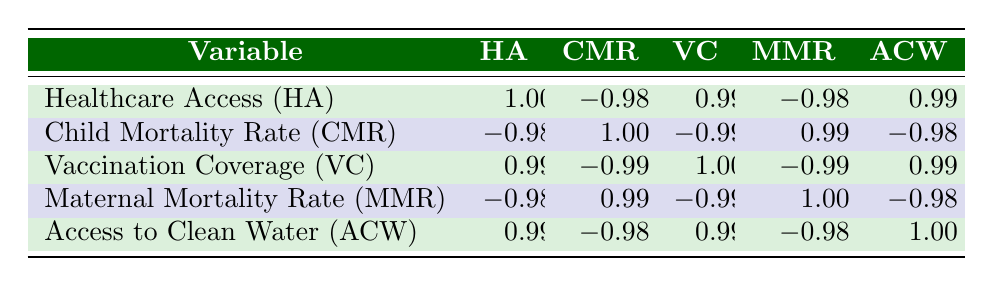What is the correlation between Healthcare Access and Child Mortality Rate? In the table, the correlation coefficient between Healthcare Access and Child Mortality Rate is -0.98. This indicates a strong negative correlation, meaning as healthcare access increases, the child mortality rate decreases.
Answer: -0.98 Which region has a higher Vaccination Coverage, Rural or Urban? By looking at the table, Urban areas have a Vaccination Coverage of 90, while Rural areas have a coverage of 70. Thus, Urban areas have a higher Vaccination Coverage.
Answer: Urban Is there a positive correlation between Access to Clean Water and Healthcare Access? The table shows that the correlation between Access to Clean Water and Healthcare Access is 0.99, which indicates a strong positive correlation. Thus, there is a positive correlation between the two.
Answer: Yes What is the average Maternal Mortality Rate in Rural areas? The Maternal Mortality Rates in Rural areas are 175 and 190. To find the average, we sum these values: 175 + 190 = 365, and divide by the number of entries (2): 365/2 = 182.5. Therefore, the average is 182.5.
Answer: 182.5 Does an increase in Vaccination Coverage correlate with a decrease in Child Mortality Rate? The correlation coefficient between Vaccination Coverage and Child Mortality Rate is -0.99, indicating a strong negative correlation. Hence, an increase in Vaccination Coverage is associated with a decrease in Child Mortality Rate.
Answer: Yes What is the difference in Healthcare Access between Urban and Rural areas? Urban areas have a Healthcare Access score of 85, while Rural areas have a score of 65. The difference can be calculated as 85 - 65 = 20. Therefore, Urban areas have 20 more points in Healthcare Access than Rural areas.
Answer: 20 What is the highest value of Access to Clean Water found in the table? The Access to Clean Water values are 95, 80, 98, 75, and 70. The highest value among these is 98, which is found in Urban areas.
Answer: 98 Do both regions show a negative correlation between Healthcare Access and Maternal Mortality Rate? The table indicates that the correlation between Healthcare Access and Maternal Mortality Rate is -0.98, which applies to both Urban and Rural areas. Therefore, both regions show a negative correlation.
Answer: Yes 